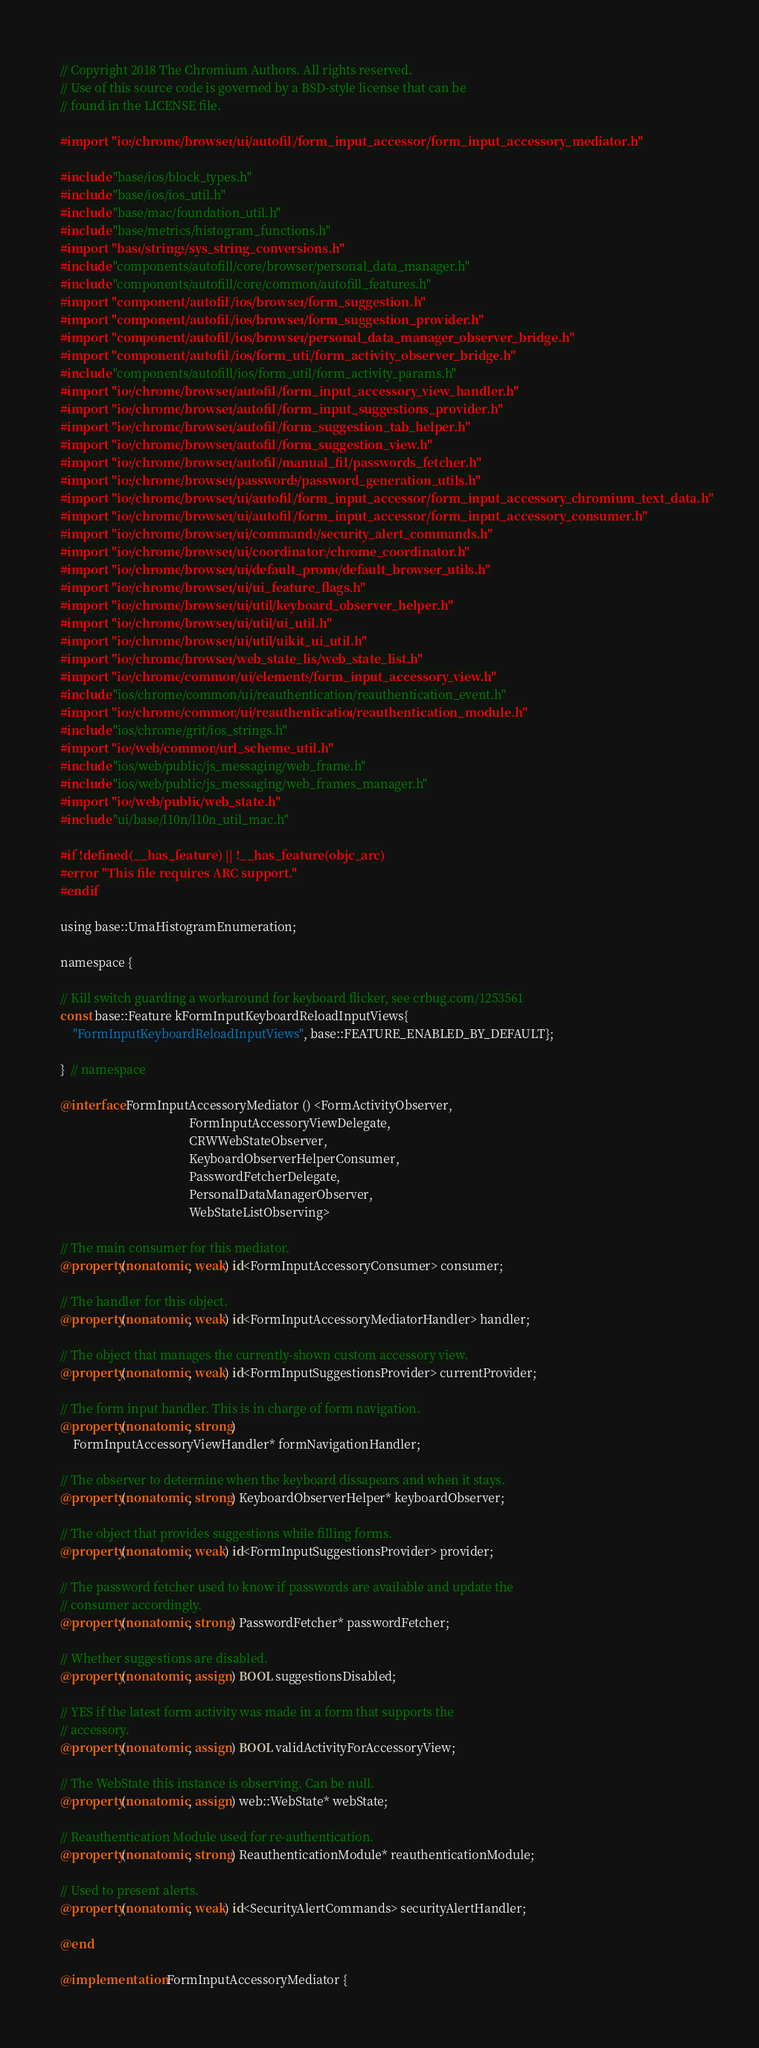Convert code to text. <code><loc_0><loc_0><loc_500><loc_500><_ObjectiveC_>// Copyright 2018 The Chromium Authors. All rights reserved.
// Use of this source code is governed by a BSD-style license that can be
// found in the LICENSE file.

#import "ios/chrome/browser/ui/autofill/form_input_accessory/form_input_accessory_mediator.h"

#include "base/ios/block_types.h"
#include "base/ios/ios_util.h"
#include "base/mac/foundation_util.h"
#include "base/metrics/histogram_functions.h"
#import "base/strings/sys_string_conversions.h"
#include "components/autofill/core/browser/personal_data_manager.h"
#include "components/autofill/core/common/autofill_features.h"
#import "components/autofill/ios/browser/form_suggestion.h"
#import "components/autofill/ios/browser/form_suggestion_provider.h"
#import "components/autofill/ios/browser/personal_data_manager_observer_bridge.h"
#import "components/autofill/ios/form_util/form_activity_observer_bridge.h"
#include "components/autofill/ios/form_util/form_activity_params.h"
#import "ios/chrome/browser/autofill/form_input_accessory_view_handler.h"
#import "ios/chrome/browser/autofill/form_input_suggestions_provider.h"
#import "ios/chrome/browser/autofill/form_suggestion_tab_helper.h"
#import "ios/chrome/browser/autofill/form_suggestion_view.h"
#import "ios/chrome/browser/autofill/manual_fill/passwords_fetcher.h"
#import "ios/chrome/browser/passwords/password_generation_utils.h"
#import "ios/chrome/browser/ui/autofill/form_input_accessory/form_input_accessory_chromium_text_data.h"
#import "ios/chrome/browser/ui/autofill/form_input_accessory/form_input_accessory_consumer.h"
#import "ios/chrome/browser/ui/commands/security_alert_commands.h"
#import "ios/chrome/browser/ui/coordinators/chrome_coordinator.h"
#import "ios/chrome/browser/ui/default_promo/default_browser_utils.h"
#import "ios/chrome/browser/ui/ui_feature_flags.h"
#import "ios/chrome/browser/ui/util/keyboard_observer_helper.h"
#import "ios/chrome/browser/ui/util/ui_util.h"
#import "ios/chrome/browser/ui/util/uikit_ui_util.h"
#import "ios/chrome/browser/web_state_list/web_state_list.h"
#import "ios/chrome/common/ui/elements/form_input_accessory_view.h"
#include "ios/chrome/common/ui/reauthentication/reauthentication_event.h"
#import "ios/chrome/common/ui/reauthentication/reauthentication_module.h"
#include "ios/chrome/grit/ios_strings.h"
#import "ios/web/common/url_scheme_util.h"
#include "ios/web/public/js_messaging/web_frame.h"
#include "ios/web/public/js_messaging/web_frames_manager.h"
#import "ios/web/public/web_state.h"
#include "ui/base/l10n/l10n_util_mac.h"

#if !defined(__has_feature) || !__has_feature(objc_arc)
#error "This file requires ARC support."
#endif

using base::UmaHistogramEnumeration;

namespace {

// Kill switch guarding a workaround for keyboard flicker, see crbug.com/1253561
const base::Feature kFormInputKeyboardReloadInputViews{
    "FormInputKeyboardReloadInputViews", base::FEATURE_ENABLED_BY_DEFAULT};

}  // namespace

@interface FormInputAccessoryMediator () <FormActivityObserver,
                                          FormInputAccessoryViewDelegate,
                                          CRWWebStateObserver,
                                          KeyboardObserverHelperConsumer,
                                          PasswordFetcherDelegate,
                                          PersonalDataManagerObserver,
                                          WebStateListObserving>

// The main consumer for this mediator.
@property(nonatomic, weak) id<FormInputAccessoryConsumer> consumer;

// The handler for this object.
@property(nonatomic, weak) id<FormInputAccessoryMediatorHandler> handler;

// The object that manages the currently-shown custom accessory view.
@property(nonatomic, weak) id<FormInputSuggestionsProvider> currentProvider;

// The form input handler. This is in charge of form navigation.
@property(nonatomic, strong)
    FormInputAccessoryViewHandler* formNavigationHandler;

// The observer to determine when the keyboard dissapears and when it stays.
@property(nonatomic, strong) KeyboardObserverHelper* keyboardObserver;

// The object that provides suggestions while filling forms.
@property(nonatomic, weak) id<FormInputSuggestionsProvider> provider;

// The password fetcher used to know if passwords are available and update the
// consumer accordingly.
@property(nonatomic, strong) PasswordFetcher* passwordFetcher;

// Whether suggestions are disabled.
@property(nonatomic, assign) BOOL suggestionsDisabled;

// YES if the latest form activity was made in a form that supports the
// accessory.
@property(nonatomic, assign) BOOL validActivityForAccessoryView;

// The WebState this instance is observing. Can be null.
@property(nonatomic, assign) web::WebState* webState;

// Reauthentication Module used for re-authentication.
@property(nonatomic, strong) ReauthenticationModule* reauthenticationModule;

// Used to present alerts.
@property(nonatomic, weak) id<SecurityAlertCommands> securityAlertHandler;

@end

@implementation FormInputAccessoryMediator {</code> 